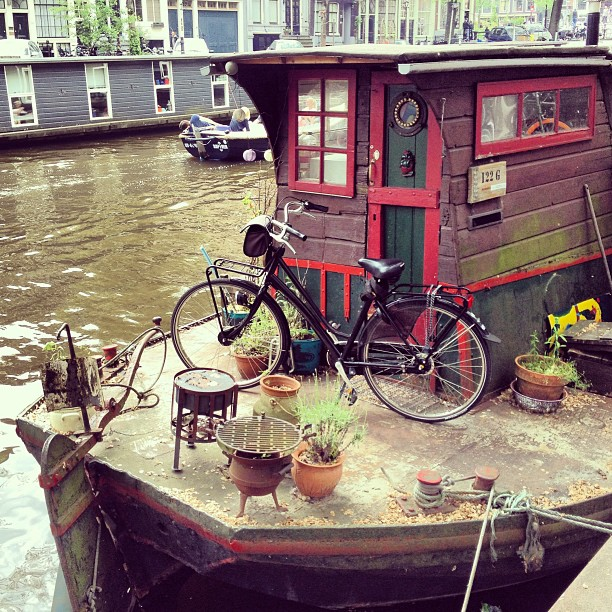Describe the atmosphere surrounding the houseboat depicted. The scene captures a quaint and relaxing atmosphere, typical of houseboats moored in tranquil waterways. Decorative plants and a variety of small items add a personal touch to the scene, suggesting a lived-in, cozy space. 